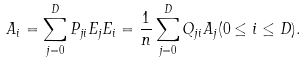<formula> <loc_0><loc_0><loc_500><loc_500>A _ { i } = \sum _ { j = 0 } ^ { D } P _ { j i } E _ { j } E _ { i } = \frac { 1 } { n } \sum _ { j = 0 } ^ { D } Q _ { j i } A _ { j } ( 0 \leq i \leq D ) .</formula> 